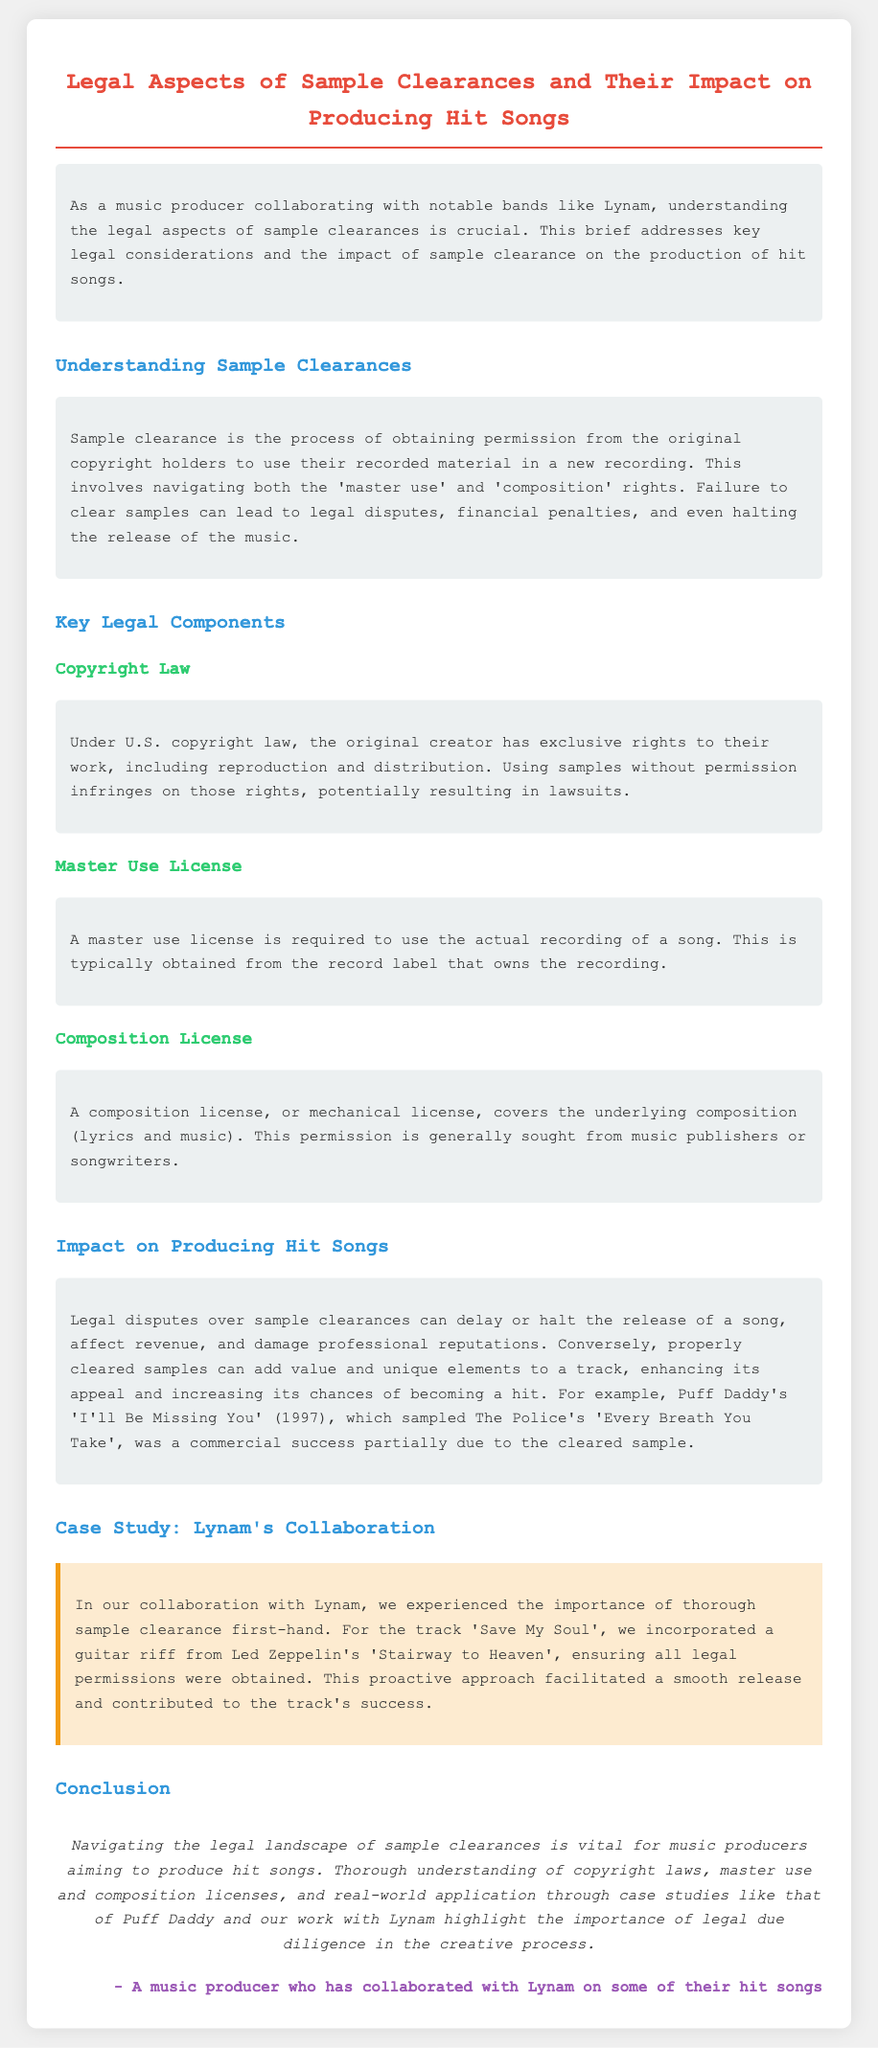What is the title of the document? The title is presented at the top of the document, highlighting its main focus.
Answer: Legal Aspects of Sample Clearances and Their Impact on Producing Hit Songs What is required to use the actual recording of a song? The document specifies this requirement under the Master Use License section.
Answer: Master use license What song includes a sample from The Police? The example song is mentioned in the Impact section, illustrating the importance of cleared samples.
Answer: I'll Be Missing You Who are the copyright holders that need to grant permission for sample use? The document details that original creators are the copyright holders referred to in the Copyright Law section.
Answer: Original creators Which track did Lynam collaborate on that involved sample clearance? The specific track is highlighted in the case study as an example of successful sample clearance.
Answer: Save My Soul What can result from failing to clear samples? The failures are discussed in the Understanding Sample Clearances section, outlining potential consequences.
Answer: Legal disputes In what year was Puff Daddy's 'I'll Be Missing You' released? The year of release is noted in the Impact section as part of a successful case study.
Answer: 1997 What does a composition license cover? The content explains the coverage of this license in the relevant section.
Answer: Underlying composition What is the main purpose of sample clearances according to the document? The document outlines this purpose in the introduction, explaining its significance for music producers.
Answer: Obtaining permission 